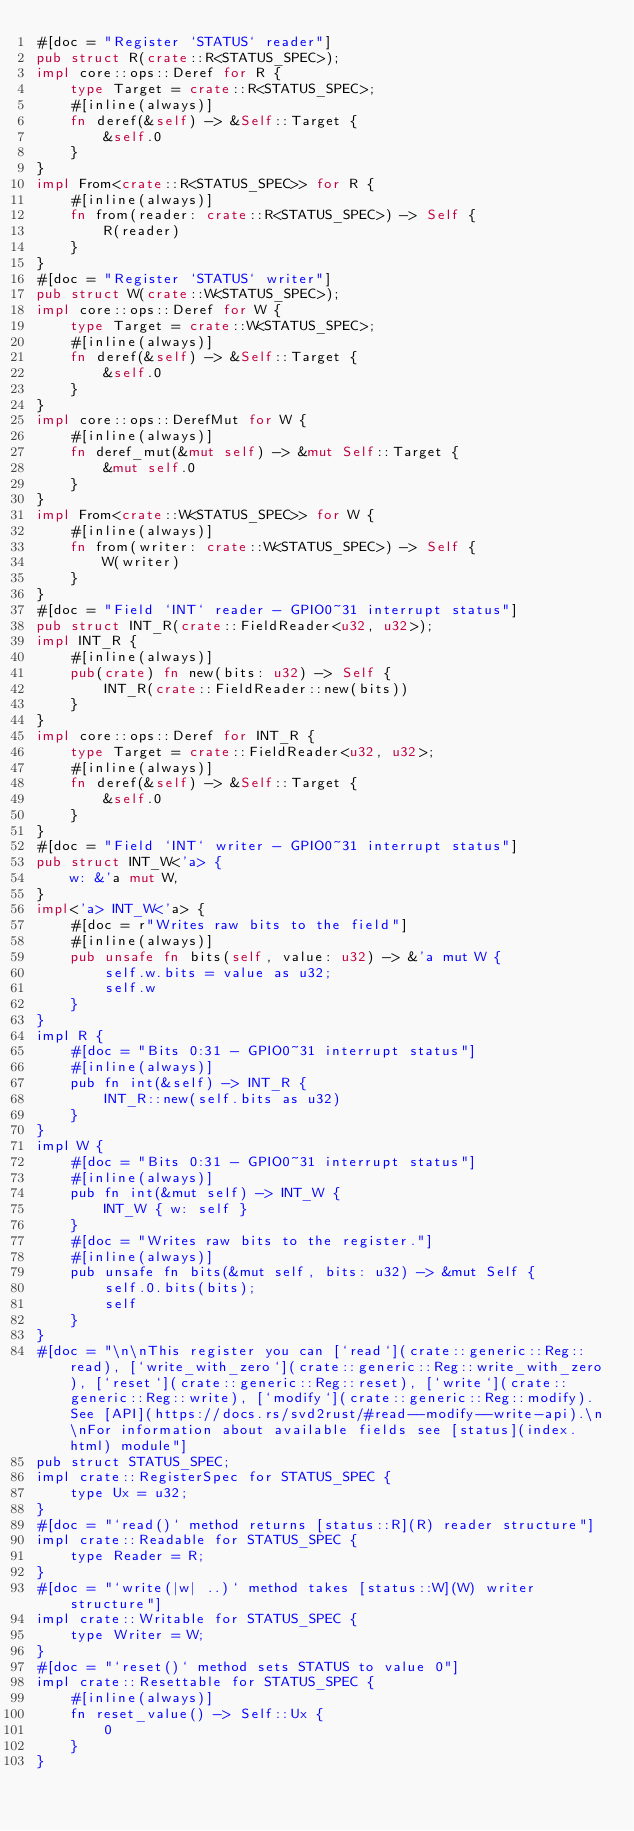Convert code to text. <code><loc_0><loc_0><loc_500><loc_500><_Rust_>#[doc = "Register `STATUS` reader"]
pub struct R(crate::R<STATUS_SPEC>);
impl core::ops::Deref for R {
    type Target = crate::R<STATUS_SPEC>;
    #[inline(always)]
    fn deref(&self) -> &Self::Target {
        &self.0
    }
}
impl From<crate::R<STATUS_SPEC>> for R {
    #[inline(always)]
    fn from(reader: crate::R<STATUS_SPEC>) -> Self {
        R(reader)
    }
}
#[doc = "Register `STATUS` writer"]
pub struct W(crate::W<STATUS_SPEC>);
impl core::ops::Deref for W {
    type Target = crate::W<STATUS_SPEC>;
    #[inline(always)]
    fn deref(&self) -> &Self::Target {
        &self.0
    }
}
impl core::ops::DerefMut for W {
    #[inline(always)]
    fn deref_mut(&mut self) -> &mut Self::Target {
        &mut self.0
    }
}
impl From<crate::W<STATUS_SPEC>> for W {
    #[inline(always)]
    fn from(writer: crate::W<STATUS_SPEC>) -> Self {
        W(writer)
    }
}
#[doc = "Field `INT` reader - GPIO0~31 interrupt status"]
pub struct INT_R(crate::FieldReader<u32, u32>);
impl INT_R {
    #[inline(always)]
    pub(crate) fn new(bits: u32) -> Self {
        INT_R(crate::FieldReader::new(bits))
    }
}
impl core::ops::Deref for INT_R {
    type Target = crate::FieldReader<u32, u32>;
    #[inline(always)]
    fn deref(&self) -> &Self::Target {
        &self.0
    }
}
#[doc = "Field `INT` writer - GPIO0~31 interrupt status"]
pub struct INT_W<'a> {
    w: &'a mut W,
}
impl<'a> INT_W<'a> {
    #[doc = r"Writes raw bits to the field"]
    #[inline(always)]
    pub unsafe fn bits(self, value: u32) -> &'a mut W {
        self.w.bits = value as u32;
        self.w
    }
}
impl R {
    #[doc = "Bits 0:31 - GPIO0~31 interrupt status"]
    #[inline(always)]
    pub fn int(&self) -> INT_R {
        INT_R::new(self.bits as u32)
    }
}
impl W {
    #[doc = "Bits 0:31 - GPIO0~31 interrupt status"]
    #[inline(always)]
    pub fn int(&mut self) -> INT_W {
        INT_W { w: self }
    }
    #[doc = "Writes raw bits to the register."]
    #[inline(always)]
    pub unsafe fn bits(&mut self, bits: u32) -> &mut Self {
        self.0.bits(bits);
        self
    }
}
#[doc = "\n\nThis register you can [`read`](crate::generic::Reg::read), [`write_with_zero`](crate::generic::Reg::write_with_zero), [`reset`](crate::generic::Reg::reset), [`write`](crate::generic::Reg::write), [`modify`](crate::generic::Reg::modify). See [API](https://docs.rs/svd2rust/#read--modify--write-api).\n\nFor information about available fields see [status](index.html) module"]
pub struct STATUS_SPEC;
impl crate::RegisterSpec for STATUS_SPEC {
    type Ux = u32;
}
#[doc = "`read()` method returns [status::R](R) reader structure"]
impl crate::Readable for STATUS_SPEC {
    type Reader = R;
}
#[doc = "`write(|w| ..)` method takes [status::W](W) writer structure"]
impl crate::Writable for STATUS_SPEC {
    type Writer = W;
}
#[doc = "`reset()` method sets STATUS to value 0"]
impl crate::Resettable for STATUS_SPEC {
    #[inline(always)]
    fn reset_value() -> Self::Ux {
        0
    }
}
</code> 